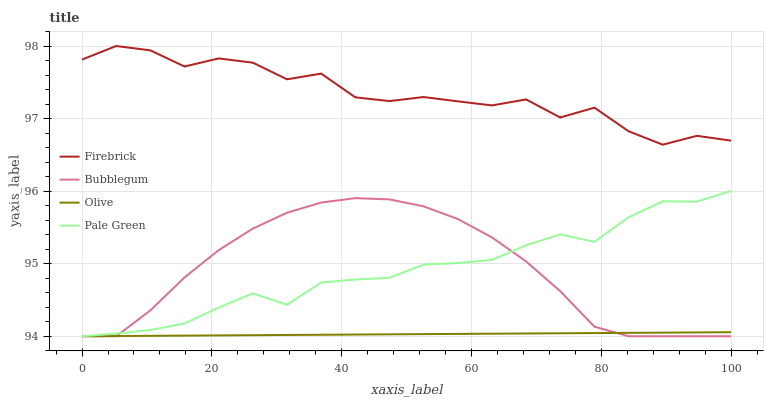Does Olive have the minimum area under the curve?
Answer yes or no. Yes. Does Firebrick have the maximum area under the curve?
Answer yes or no. Yes. Does Pale Green have the minimum area under the curve?
Answer yes or no. No. Does Pale Green have the maximum area under the curve?
Answer yes or no. No. Is Olive the smoothest?
Answer yes or no. Yes. Is Firebrick the roughest?
Answer yes or no. Yes. Is Pale Green the smoothest?
Answer yes or no. No. Is Pale Green the roughest?
Answer yes or no. No. Does Olive have the lowest value?
Answer yes or no. Yes. Does Firebrick have the lowest value?
Answer yes or no. No. Does Firebrick have the highest value?
Answer yes or no. Yes. Does Pale Green have the highest value?
Answer yes or no. No. Is Pale Green less than Firebrick?
Answer yes or no. Yes. Is Firebrick greater than Olive?
Answer yes or no. Yes. Does Olive intersect Pale Green?
Answer yes or no. Yes. Is Olive less than Pale Green?
Answer yes or no. No. Is Olive greater than Pale Green?
Answer yes or no. No. Does Pale Green intersect Firebrick?
Answer yes or no. No. 